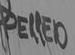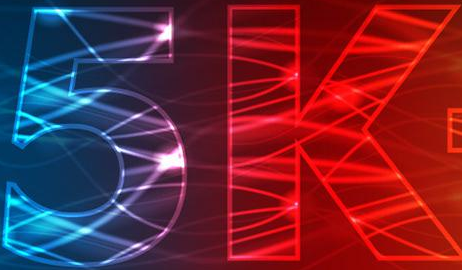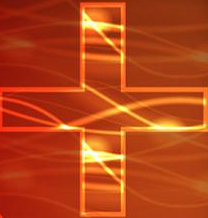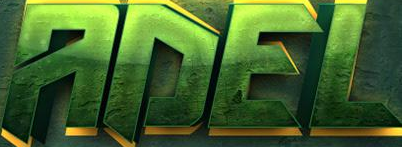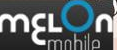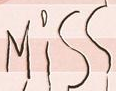What text appears in these images from left to right, separated by a semicolon? PELLED; 5k; +; ADEL; mɛLon; Miss 